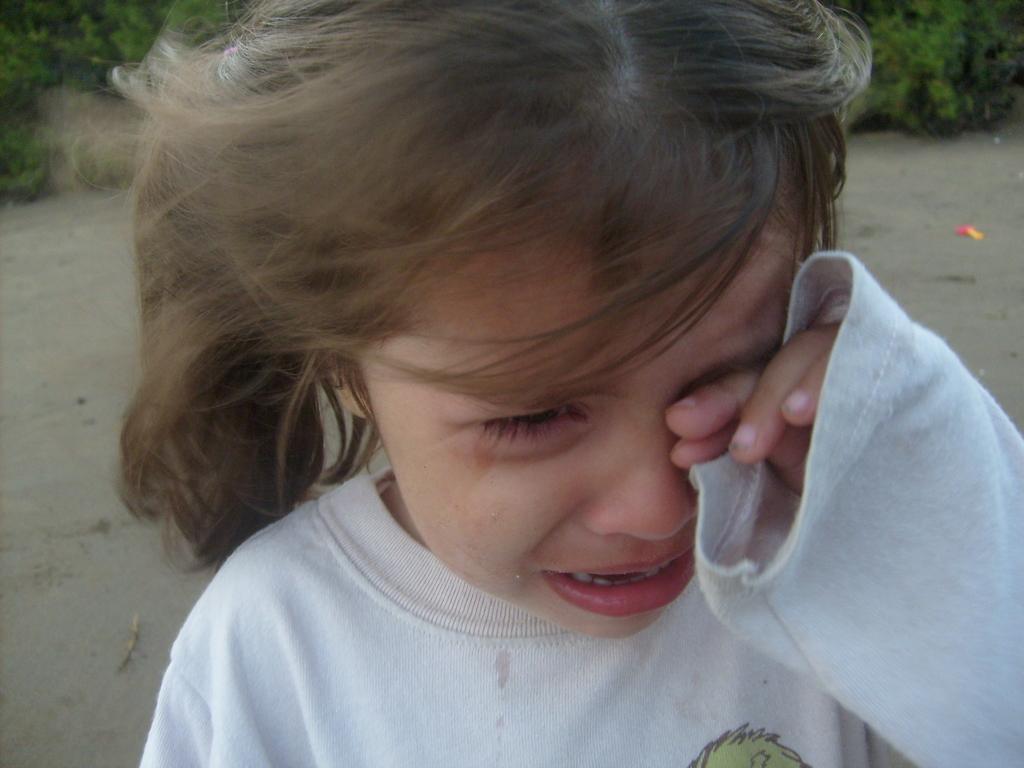Please provide a concise description of this image. In this image I see a girl who is wearing white t-shirt and I see that she is crying. In the background I see the path and I see green plants. 